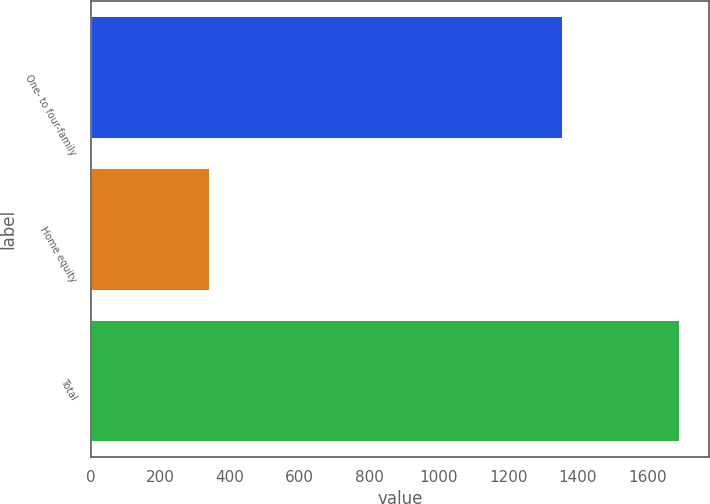<chart> <loc_0><loc_0><loc_500><loc_500><bar_chart><fcel>One- to four-family<fcel>Home equity<fcel>Total<nl><fcel>1353.9<fcel>338.6<fcel>1692.5<nl></chart> 